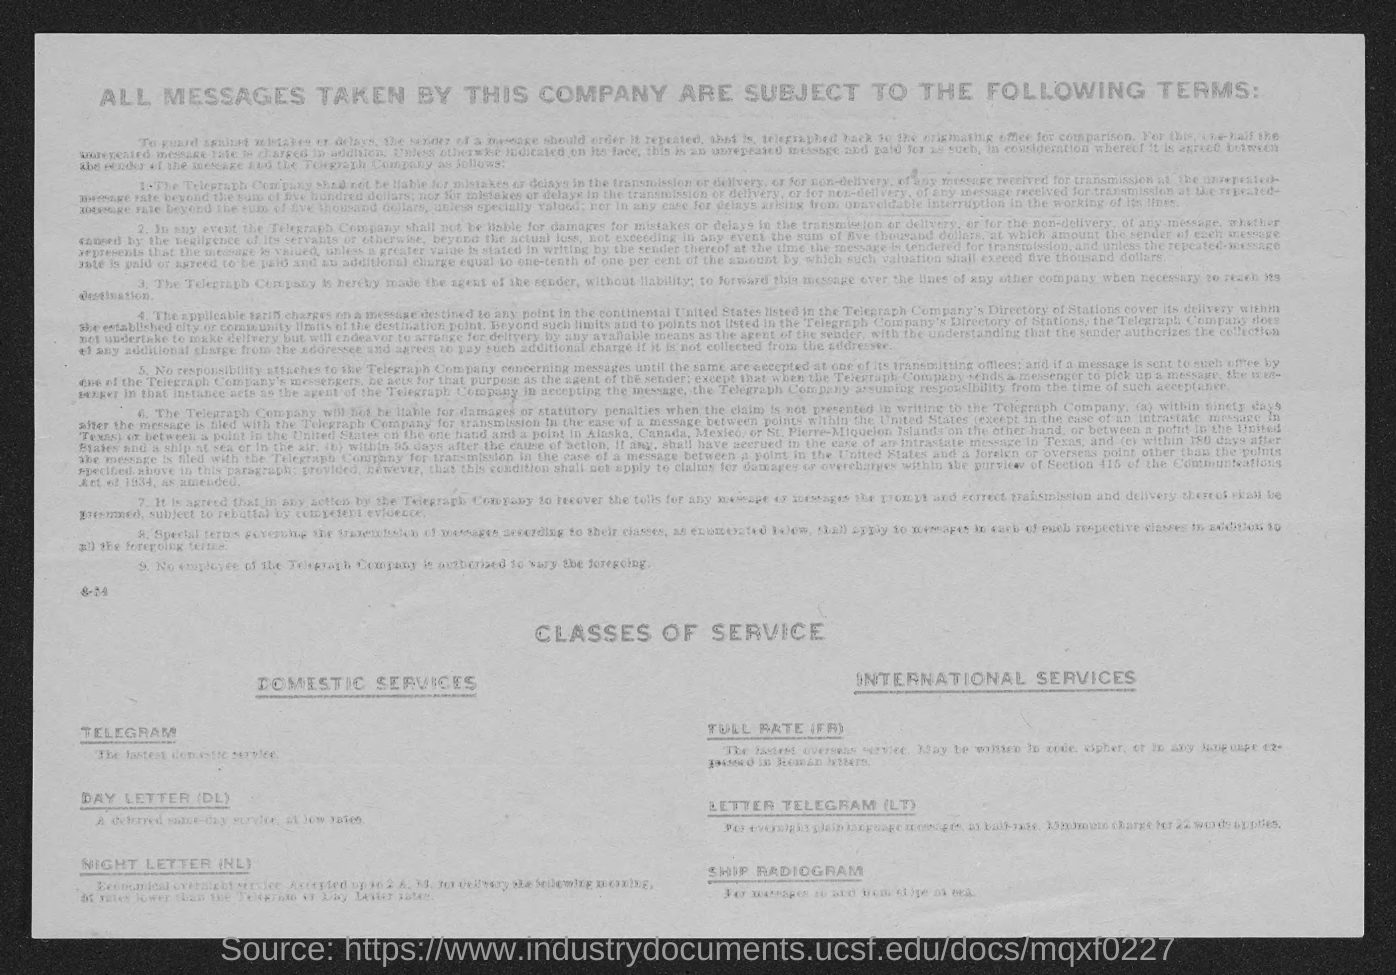Telegram comes under which class of service?
Provide a succinct answer. Domestic services. Letter Telegram comes under which class of service?
Keep it short and to the point. International services. What does dl stand for?
Provide a succinct answer. Day letter. 